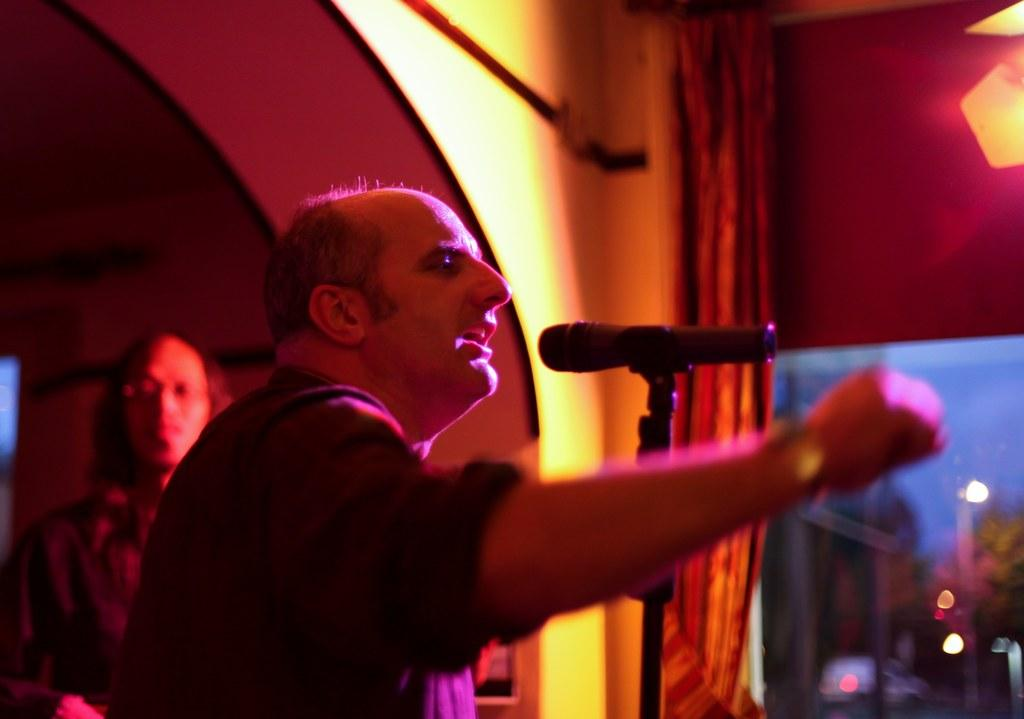What is the man in the image doing? The man is standing in front of a mic and a stand. Who else is present in the image? There is another person on the left side of the man. What can be seen in the background of the image? There is a curtain and a wall in the background of the image. What type of lettuce is being used as a prop by the man in the image? There is no lettuce present in the image. 